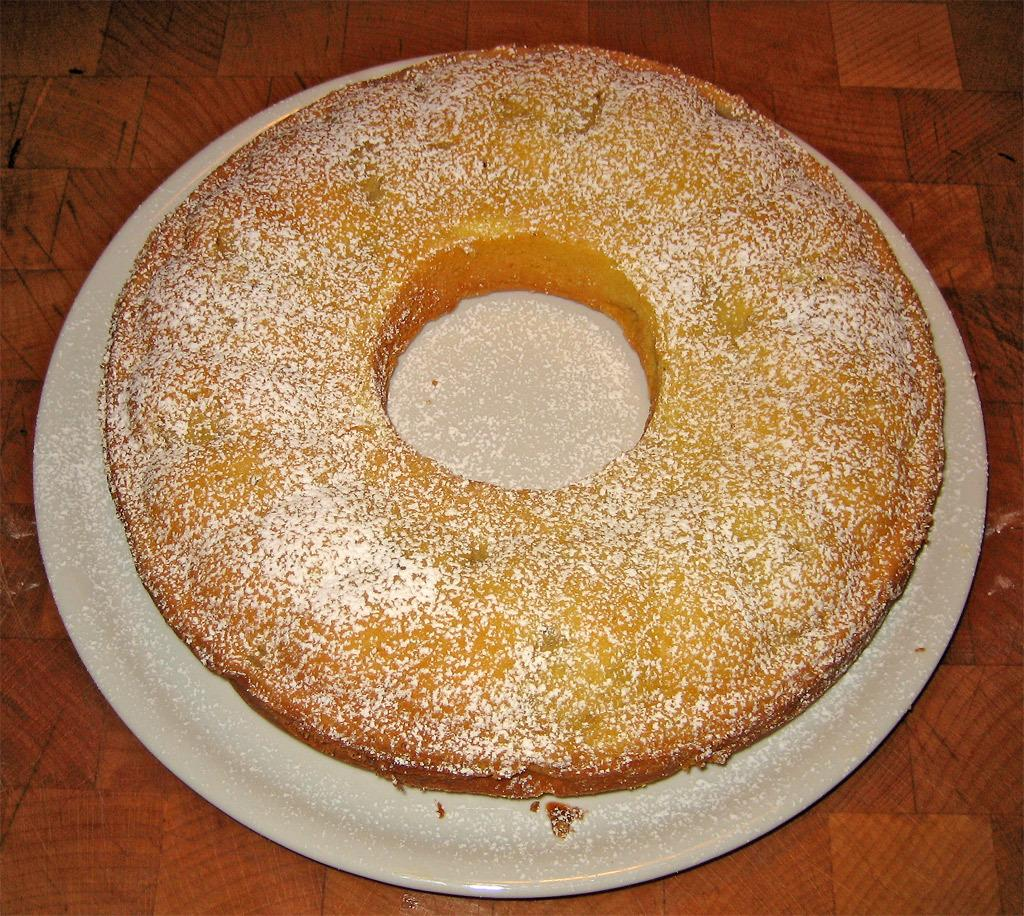What is the color of the platter in the image? The platter in the image is white. What is on the platter? The platter contains a doughnut. On what surface is the platter placed? The platter is placed on a wooden table. Are there any snails crawling on the wooden table in the image? There is no mention of snails in the image, so we cannot determine if any are present. 